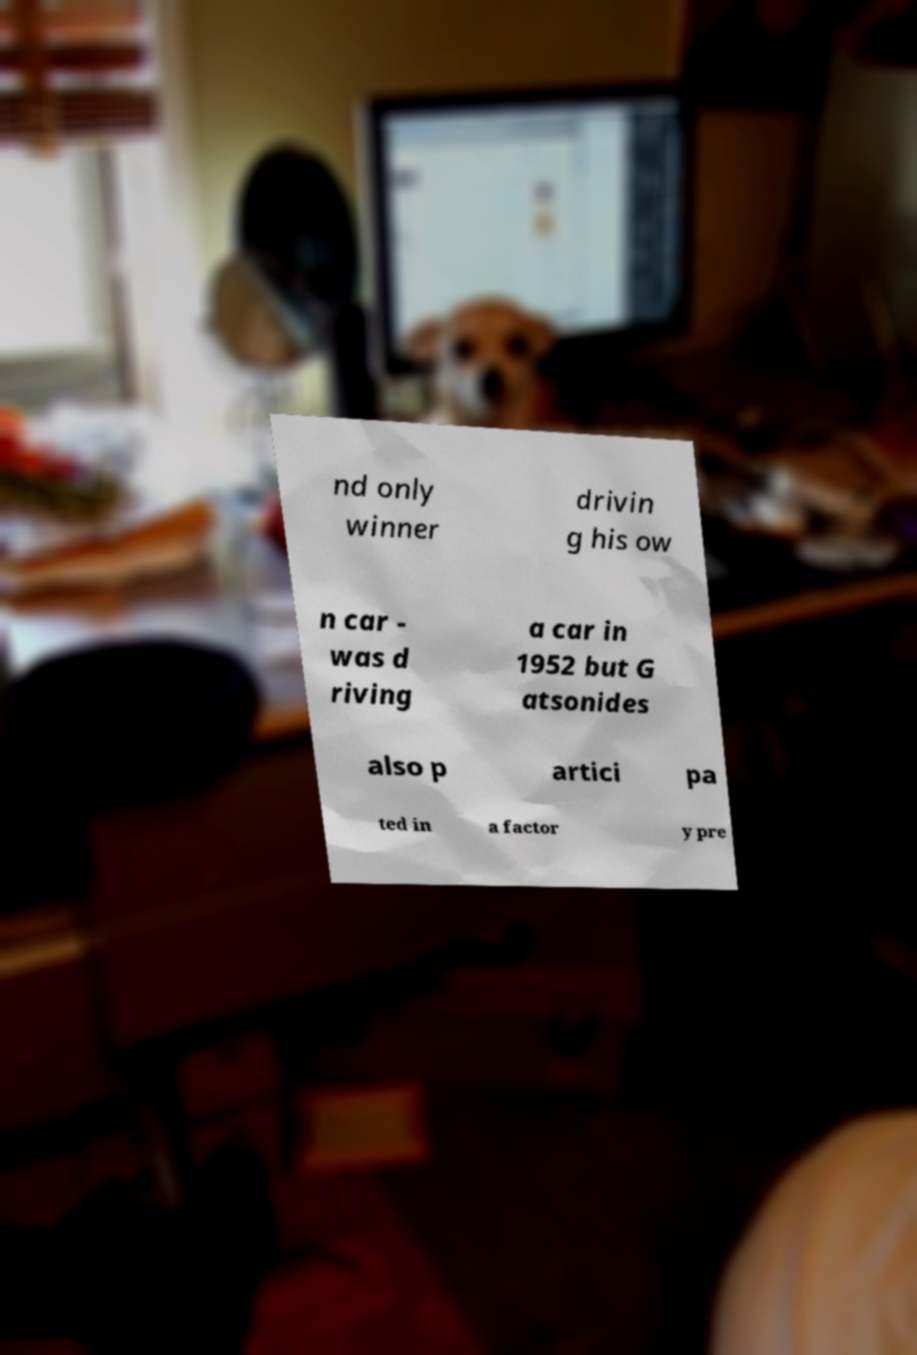Could you assist in decoding the text presented in this image and type it out clearly? nd only winner drivin g his ow n car - was d riving a car in 1952 but G atsonides also p artici pa ted in a factor y pre 